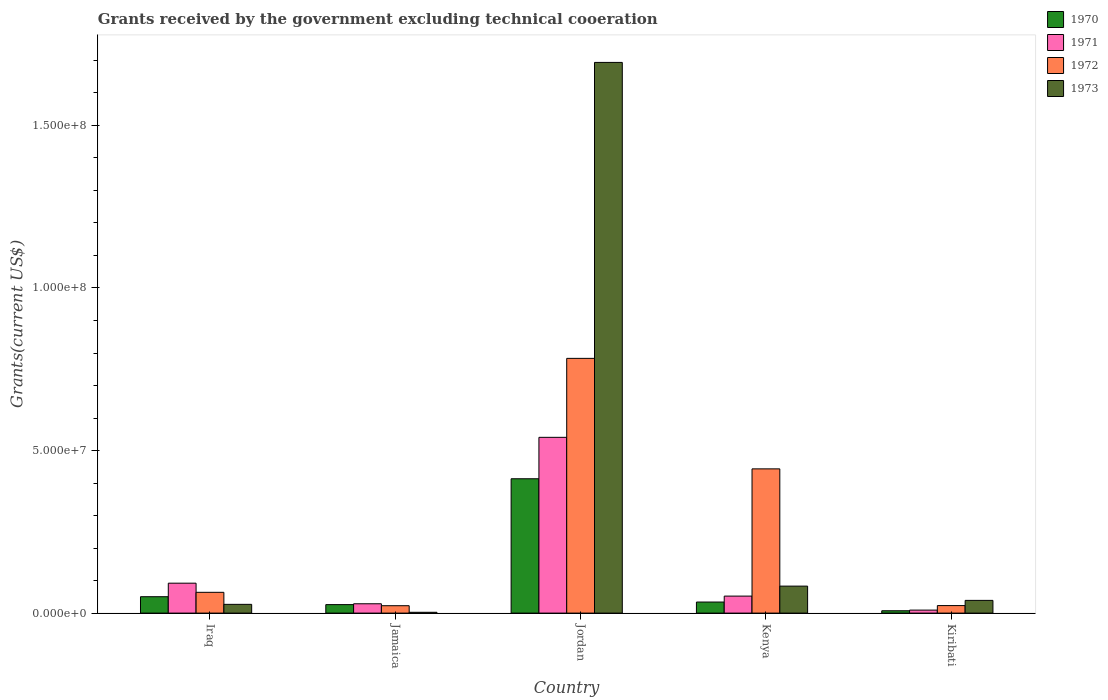How many different coloured bars are there?
Keep it short and to the point. 4. How many groups of bars are there?
Make the answer very short. 5. How many bars are there on the 3rd tick from the left?
Provide a short and direct response. 4. How many bars are there on the 2nd tick from the right?
Give a very brief answer. 4. What is the label of the 4th group of bars from the left?
Provide a succinct answer. Kenya. What is the total grants received by the government in 1970 in Kenya?
Give a very brief answer. 3.40e+06. Across all countries, what is the maximum total grants received by the government in 1970?
Offer a terse response. 4.13e+07. Across all countries, what is the minimum total grants received by the government in 1972?
Give a very brief answer. 2.27e+06. In which country was the total grants received by the government in 1970 maximum?
Keep it short and to the point. Jordan. In which country was the total grants received by the government in 1972 minimum?
Ensure brevity in your answer.  Jamaica. What is the total total grants received by the government in 1971 in the graph?
Give a very brief answer. 7.23e+07. What is the difference between the total grants received by the government in 1972 in Kenya and that in Kiribati?
Provide a succinct answer. 4.20e+07. What is the difference between the total grants received by the government in 1971 in Kenya and the total grants received by the government in 1973 in Jamaica?
Your answer should be compact. 4.98e+06. What is the average total grants received by the government in 1972 per country?
Make the answer very short. 2.67e+07. What is the difference between the total grants received by the government of/in 1973 and total grants received by the government of/in 1972 in Jordan?
Offer a very short reply. 9.10e+07. What is the ratio of the total grants received by the government in 1972 in Jamaica to that in Kiribati?
Your answer should be compact. 0.98. What is the difference between the highest and the second highest total grants received by the government in 1972?
Give a very brief answer. 7.20e+07. What is the difference between the highest and the lowest total grants received by the government in 1973?
Your response must be concise. 1.69e+08. What does the 2nd bar from the left in Jamaica represents?
Your answer should be very brief. 1971. Is it the case that in every country, the sum of the total grants received by the government in 1971 and total grants received by the government in 1970 is greater than the total grants received by the government in 1972?
Give a very brief answer. No. How many bars are there?
Ensure brevity in your answer.  20. How many countries are there in the graph?
Provide a succinct answer. 5. What is the difference between two consecutive major ticks on the Y-axis?
Make the answer very short. 5.00e+07. Does the graph contain grids?
Your response must be concise. No. How many legend labels are there?
Your answer should be very brief. 4. What is the title of the graph?
Keep it short and to the point. Grants received by the government excluding technical cooeration. What is the label or title of the Y-axis?
Your answer should be very brief. Grants(current US$). What is the Grants(current US$) of 1970 in Iraq?
Your response must be concise. 5.04e+06. What is the Grants(current US$) in 1971 in Iraq?
Provide a succinct answer. 9.20e+06. What is the Grants(current US$) in 1972 in Iraq?
Provide a succinct answer. 6.39e+06. What is the Grants(current US$) of 1973 in Iraq?
Provide a short and direct response. 2.69e+06. What is the Grants(current US$) in 1970 in Jamaica?
Your answer should be very brief. 2.61e+06. What is the Grants(current US$) of 1971 in Jamaica?
Provide a short and direct response. 2.87e+06. What is the Grants(current US$) in 1972 in Jamaica?
Keep it short and to the point. 2.27e+06. What is the Grants(current US$) of 1970 in Jordan?
Give a very brief answer. 4.13e+07. What is the Grants(current US$) of 1971 in Jordan?
Ensure brevity in your answer.  5.41e+07. What is the Grants(current US$) of 1972 in Jordan?
Provide a short and direct response. 7.84e+07. What is the Grants(current US$) of 1973 in Jordan?
Make the answer very short. 1.69e+08. What is the Grants(current US$) of 1970 in Kenya?
Offer a very short reply. 3.40e+06. What is the Grants(current US$) in 1971 in Kenya?
Offer a very short reply. 5.23e+06. What is the Grants(current US$) in 1972 in Kenya?
Your answer should be very brief. 4.44e+07. What is the Grants(current US$) in 1973 in Kenya?
Your response must be concise. 8.30e+06. What is the Grants(current US$) in 1970 in Kiribati?
Keep it short and to the point. 7.20e+05. What is the Grants(current US$) of 1971 in Kiribati?
Make the answer very short. 9.20e+05. What is the Grants(current US$) of 1972 in Kiribati?
Provide a succinct answer. 2.31e+06. What is the Grants(current US$) of 1973 in Kiribati?
Offer a very short reply. 3.91e+06. Across all countries, what is the maximum Grants(current US$) in 1970?
Your answer should be compact. 4.13e+07. Across all countries, what is the maximum Grants(current US$) in 1971?
Your response must be concise. 5.41e+07. Across all countries, what is the maximum Grants(current US$) of 1972?
Provide a succinct answer. 7.84e+07. Across all countries, what is the maximum Grants(current US$) in 1973?
Keep it short and to the point. 1.69e+08. Across all countries, what is the minimum Grants(current US$) in 1970?
Provide a short and direct response. 7.20e+05. Across all countries, what is the minimum Grants(current US$) of 1971?
Your answer should be compact. 9.20e+05. Across all countries, what is the minimum Grants(current US$) in 1972?
Keep it short and to the point. 2.27e+06. What is the total Grants(current US$) in 1970 in the graph?
Give a very brief answer. 5.31e+07. What is the total Grants(current US$) of 1971 in the graph?
Ensure brevity in your answer.  7.23e+07. What is the total Grants(current US$) of 1972 in the graph?
Provide a short and direct response. 1.34e+08. What is the total Grants(current US$) of 1973 in the graph?
Your answer should be very brief. 1.85e+08. What is the difference between the Grants(current US$) of 1970 in Iraq and that in Jamaica?
Offer a terse response. 2.43e+06. What is the difference between the Grants(current US$) in 1971 in Iraq and that in Jamaica?
Your answer should be compact. 6.33e+06. What is the difference between the Grants(current US$) of 1972 in Iraq and that in Jamaica?
Provide a succinct answer. 4.12e+06. What is the difference between the Grants(current US$) in 1973 in Iraq and that in Jamaica?
Ensure brevity in your answer.  2.44e+06. What is the difference between the Grants(current US$) in 1970 in Iraq and that in Jordan?
Give a very brief answer. -3.63e+07. What is the difference between the Grants(current US$) in 1971 in Iraq and that in Jordan?
Provide a short and direct response. -4.49e+07. What is the difference between the Grants(current US$) in 1972 in Iraq and that in Jordan?
Your response must be concise. -7.20e+07. What is the difference between the Grants(current US$) in 1973 in Iraq and that in Jordan?
Make the answer very short. -1.67e+08. What is the difference between the Grants(current US$) of 1970 in Iraq and that in Kenya?
Offer a terse response. 1.64e+06. What is the difference between the Grants(current US$) in 1971 in Iraq and that in Kenya?
Offer a terse response. 3.97e+06. What is the difference between the Grants(current US$) of 1972 in Iraq and that in Kenya?
Make the answer very short. -3.80e+07. What is the difference between the Grants(current US$) in 1973 in Iraq and that in Kenya?
Give a very brief answer. -5.61e+06. What is the difference between the Grants(current US$) in 1970 in Iraq and that in Kiribati?
Provide a succinct answer. 4.32e+06. What is the difference between the Grants(current US$) of 1971 in Iraq and that in Kiribati?
Ensure brevity in your answer.  8.28e+06. What is the difference between the Grants(current US$) in 1972 in Iraq and that in Kiribati?
Provide a short and direct response. 4.08e+06. What is the difference between the Grants(current US$) of 1973 in Iraq and that in Kiribati?
Your answer should be very brief. -1.22e+06. What is the difference between the Grants(current US$) in 1970 in Jamaica and that in Jordan?
Give a very brief answer. -3.87e+07. What is the difference between the Grants(current US$) of 1971 in Jamaica and that in Jordan?
Your answer should be compact. -5.12e+07. What is the difference between the Grants(current US$) of 1972 in Jamaica and that in Jordan?
Your answer should be very brief. -7.61e+07. What is the difference between the Grants(current US$) of 1973 in Jamaica and that in Jordan?
Offer a very short reply. -1.69e+08. What is the difference between the Grants(current US$) of 1970 in Jamaica and that in Kenya?
Provide a short and direct response. -7.90e+05. What is the difference between the Grants(current US$) of 1971 in Jamaica and that in Kenya?
Your answer should be very brief. -2.36e+06. What is the difference between the Grants(current US$) in 1972 in Jamaica and that in Kenya?
Ensure brevity in your answer.  -4.21e+07. What is the difference between the Grants(current US$) of 1973 in Jamaica and that in Kenya?
Give a very brief answer. -8.05e+06. What is the difference between the Grants(current US$) in 1970 in Jamaica and that in Kiribati?
Ensure brevity in your answer.  1.89e+06. What is the difference between the Grants(current US$) in 1971 in Jamaica and that in Kiribati?
Offer a terse response. 1.95e+06. What is the difference between the Grants(current US$) in 1973 in Jamaica and that in Kiribati?
Provide a succinct answer. -3.66e+06. What is the difference between the Grants(current US$) of 1970 in Jordan and that in Kenya?
Provide a succinct answer. 3.79e+07. What is the difference between the Grants(current US$) of 1971 in Jordan and that in Kenya?
Your answer should be very brief. 4.88e+07. What is the difference between the Grants(current US$) of 1972 in Jordan and that in Kenya?
Give a very brief answer. 3.40e+07. What is the difference between the Grants(current US$) of 1973 in Jordan and that in Kenya?
Keep it short and to the point. 1.61e+08. What is the difference between the Grants(current US$) of 1970 in Jordan and that in Kiribati?
Give a very brief answer. 4.06e+07. What is the difference between the Grants(current US$) of 1971 in Jordan and that in Kiribati?
Provide a succinct answer. 5.31e+07. What is the difference between the Grants(current US$) in 1972 in Jordan and that in Kiribati?
Give a very brief answer. 7.60e+07. What is the difference between the Grants(current US$) of 1973 in Jordan and that in Kiribati?
Give a very brief answer. 1.65e+08. What is the difference between the Grants(current US$) of 1970 in Kenya and that in Kiribati?
Provide a short and direct response. 2.68e+06. What is the difference between the Grants(current US$) of 1971 in Kenya and that in Kiribati?
Your response must be concise. 4.31e+06. What is the difference between the Grants(current US$) of 1972 in Kenya and that in Kiribati?
Keep it short and to the point. 4.20e+07. What is the difference between the Grants(current US$) of 1973 in Kenya and that in Kiribati?
Provide a succinct answer. 4.39e+06. What is the difference between the Grants(current US$) in 1970 in Iraq and the Grants(current US$) in 1971 in Jamaica?
Your answer should be very brief. 2.17e+06. What is the difference between the Grants(current US$) in 1970 in Iraq and the Grants(current US$) in 1972 in Jamaica?
Provide a short and direct response. 2.77e+06. What is the difference between the Grants(current US$) in 1970 in Iraq and the Grants(current US$) in 1973 in Jamaica?
Your answer should be very brief. 4.79e+06. What is the difference between the Grants(current US$) in 1971 in Iraq and the Grants(current US$) in 1972 in Jamaica?
Provide a succinct answer. 6.93e+06. What is the difference between the Grants(current US$) in 1971 in Iraq and the Grants(current US$) in 1973 in Jamaica?
Keep it short and to the point. 8.95e+06. What is the difference between the Grants(current US$) in 1972 in Iraq and the Grants(current US$) in 1973 in Jamaica?
Your answer should be very brief. 6.14e+06. What is the difference between the Grants(current US$) of 1970 in Iraq and the Grants(current US$) of 1971 in Jordan?
Provide a short and direct response. -4.90e+07. What is the difference between the Grants(current US$) in 1970 in Iraq and the Grants(current US$) in 1972 in Jordan?
Offer a very short reply. -7.33e+07. What is the difference between the Grants(current US$) of 1970 in Iraq and the Grants(current US$) of 1973 in Jordan?
Provide a short and direct response. -1.64e+08. What is the difference between the Grants(current US$) of 1971 in Iraq and the Grants(current US$) of 1972 in Jordan?
Keep it short and to the point. -6.92e+07. What is the difference between the Grants(current US$) in 1971 in Iraq and the Grants(current US$) in 1973 in Jordan?
Provide a succinct answer. -1.60e+08. What is the difference between the Grants(current US$) in 1972 in Iraq and the Grants(current US$) in 1973 in Jordan?
Give a very brief answer. -1.63e+08. What is the difference between the Grants(current US$) of 1970 in Iraq and the Grants(current US$) of 1972 in Kenya?
Ensure brevity in your answer.  -3.93e+07. What is the difference between the Grants(current US$) of 1970 in Iraq and the Grants(current US$) of 1973 in Kenya?
Keep it short and to the point. -3.26e+06. What is the difference between the Grants(current US$) in 1971 in Iraq and the Grants(current US$) in 1972 in Kenya?
Give a very brief answer. -3.52e+07. What is the difference between the Grants(current US$) of 1972 in Iraq and the Grants(current US$) of 1973 in Kenya?
Provide a short and direct response. -1.91e+06. What is the difference between the Grants(current US$) in 1970 in Iraq and the Grants(current US$) in 1971 in Kiribati?
Offer a terse response. 4.12e+06. What is the difference between the Grants(current US$) in 1970 in Iraq and the Grants(current US$) in 1972 in Kiribati?
Keep it short and to the point. 2.73e+06. What is the difference between the Grants(current US$) of 1970 in Iraq and the Grants(current US$) of 1973 in Kiribati?
Give a very brief answer. 1.13e+06. What is the difference between the Grants(current US$) of 1971 in Iraq and the Grants(current US$) of 1972 in Kiribati?
Provide a succinct answer. 6.89e+06. What is the difference between the Grants(current US$) in 1971 in Iraq and the Grants(current US$) in 1973 in Kiribati?
Your response must be concise. 5.29e+06. What is the difference between the Grants(current US$) in 1972 in Iraq and the Grants(current US$) in 1973 in Kiribati?
Offer a very short reply. 2.48e+06. What is the difference between the Grants(current US$) of 1970 in Jamaica and the Grants(current US$) of 1971 in Jordan?
Provide a short and direct response. -5.14e+07. What is the difference between the Grants(current US$) in 1970 in Jamaica and the Grants(current US$) in 1972 in Jordan?
Offer a terse response. -7.57e+07. What is the difference between the Grants(current US$) in 1970 in Jamaica and the Grants(current US$) in 1973 in Jordan?
Ensure brevity in your answer.  -1.67e+08. What is the difference between the Grants(current US$) of 1971 in Jamaica and the Grants(current US$) of 1972 in Jordan?
Ensure brevity in your answer.  -7.55e+07. What is the difference between the Grants(current US$) in 1971 in Jamaica and the Grants(current US$) in 1973 in Jordan?
Ensure brevity in your answer.  -1.67e+08. What is the difference between the Grants(current US$) in 1972 in Jamaica and the Grants(current US$) in 1973 in Jordan?
Provide a succinct answer. -1.67e+08. What is the difference between the Grants(current US$) in 1970 in Jamaica and the Grants(current US$) in 1971 in Kenya?
Provide a succinct answer. -2.62e+06. What is the difference between the Grants(current US$) in 1970 in Jamaica and the Grants(current US$) in 1972 in Kenya?
Your answer should be compact. -4.18e+07. What is the difference between the Grants(current US$) in 1970 in Jamaica and the Grants(current US$) in 1973 in Kenya?
Provide a succinct answer. -5.69e+06. What is the difference between the Grants(current US$) of 1971 in Jamaica and the Grants(current US$) of 1972 in Kenya?
Make the answer very short. -4.15e+07. What is the difference between the Grants(current US$) in 1971 in Jamaica and the Grants(current US$) in 1973 in Kenya?
Keep it short and to the point. -5.43e+06. What is the difference between the Grants(current US$) in 1972 in Jamaica and the Grants(current US$) in 1973 in Kenya?
Ensure brevity in your answer.  -6.03e+06. What is the difference between the Grants(current US$) of 1970 in Jamaica and the Grants(current US$) of 1971 in Kiribati?
Make the answer very short. 1.69e+06. What is the difference between the Grants(current US$) of 1970 in Jamaica and the Grants(current US$) of 1973 in Kiribati?
Ensure brevity in your answer.  -1.30e+06. What is the difference between the Grants(current US$) of 1971 in Jamaica and the Grants(current US$) of 1972 in Kiribati?
Your answer should be very brief. 5.60e+05. What is the difference between the Grants(current US$) in 1971 in Jamaica and the Grants(current US$) in 1973 in Kiribati?
Your answer should be very brief. -1.04e+06. What is the difference between the Grants(current US$) in 1972 in Jamaica and the Grants(current US$) in 1973 in Kiribati?
Offer a terse response. -1.64e+06. What is the difference between the Grants(current US$) of 1970 in Jordan and the Grants(current US$) of 1971 in Kenya?
Ensure brevity in your answer.  3.61e+07. What is the difference between the Grants(current US$) in 1970 in Jordan and the Grants(current US$) in 1972 in Kenya?
Offer a terse response. -3.04e+06. What is the difference between the Grants(current US$) in 1970 in Jordan and the Grants(current US$) in 1973 in Kenya?
Provide a short and direct response. 3.30e+07. What is the difference between the Grants(current US$) of 1971 in Jordan and the Grants(current US$) of 1972 in Kenya?
Keep it short and to the point. 9.70e+06. What is the difference between the Grants(current US$) in 1971 in Jordan and the Grants(current US$) in 1973 in Kenya?
Give a very brief answer. 4.58e+07. What is the difference between the Grants(current US$) of 1972 in Jordan and the Grants(current US$) of 1973 in Kenya?
Keep it short and to the point. 7.00e+07. What is the difference between the Grants(current US$) in 1970 in Jordan and the Grants(current US$) in 1971 in Kiribati?
Keep it short and to the point. 4.04e+07. What is the difference between the Grants(current US$) in 1970 in Jordan and the Grants(current US$) in 1972 in Kiribati?
Offer a very short reply. 3.90e+07. What is the difference between the Grants(current US$) in 1970 in Jordan and the Grants(current US$) in 1973 in Kiribati?
Provide a short and direct response. 3.74e+07. What is the difference between the Grants(current US$) of 1971 in Jordan and the Grants(current US$) of 1972 in Kiribati?
Make the answer very short. 5.18e+07. What is the difference between the Grants(current US$) in 1971 in Jordan and the Grants(current US$) in 1973 in Kiribati?
Offer a terse response. 5.02e+07. What is the difference between the Grants(current US$) of 1972 in Jordan and the Grants(current US$) of 1973 in Kiribati?
Provide a succinct answer. 7.44e+07. What is the difference between the Grants(current US$) of 1970 in Kenya and the Grants(current US$) of 1971 in Kiribati?
Ensure brevity in your answer.  2.48e+06. What is the difference between the Grants(current US$) of 1970 in Kenya and the Grants(current US$) of 1972 in Kiribati?
Provide a short and direct response. 1.09e+06. What is the difference between the Grants(current US$) of 1970 in Kenya and the Grants(current US$) of 1973 in Kiribati?
Your answer should be very brief. -5.10e+05. What is the difference between the Grants(current US$) in 1971 in Kenya and the Grants(current US$) in 1972 in Kiribati?
Offer a terse response. 2.92e+06. What is the difference between the Grants(current US$) in 1971 in Kenya and the Grants(current US$) in 1973 in Kiribati?
Give a very brief answer. 1.32e+06. What is the difference between the Grants(current US$) in 1972 in Kenya and the Grants(current US$) in 1973 in Kiribati?
Keep it short and to the point. 4.04e+07. What is the average Grants(current US$) of 1970 per country?
Keep it short and to the point. 1.06e+07. What is the average Grants(current US$) of 1971 per country?
Keep it short and to the point. 1.45e+07. What is the average Grants(current US$) of 1972 per country?
Your answer should be compact. 2.67e+07. What is the average Grants(current US$) of 1973 per country?
Make the answer very short. 3.69e+07. What is the difference between the Grants(current US$) of 1970 and Grants(current US$) of 1971 in Iraq?
Ensure brevity in your answer.  -4.16e+06. What is the difference between the Grants(current US$) of 1970 and Grants(current US$) of 1972 in Iraq?
Provide a succinct answer. -1.35e+06. What is the difference between the Grants(current US$) of 1970 and Grants(current US$) of 1973 in Iraq?
Your answer should be compact. 2.35e+06. What is the difference between the Grants(current US$) in 1971 and Grants(current US$) in 1972 in Iraq?
Provide a succinct answer. 2.81e+06. What is the difference between the Grants(current US$) in 1971 and Grants(current US$) in 1973 in Iraq?
Your answer should be very brief. 6.51e+06. What is the difference between the Grants(current US$) of 1972 and Grants(current US$) of 1973 in Iraq?
Offer a terse response. 3.70e+06. What is the difference between the Grants(current US$) of 1970 and Grants(current US$) of 1971 in Jamaica?
Offer a terse response. -2.60e+05. What is the difference between the Grants(current US$) of 1970 and Grants(current US$) of 1973 in Jamaica?
Ensure brevity in your answer.  2.36e+06. What is the difference between the Grants(current US$) in 1971 and Grants(current US$) in 1973 in Jamaica?
Your response must be concise. 2.62e+06. What is the difference between the Grants(current US$) in 1972 and Grants(current US$) in 1973 in Jamaica?
Your response must be concise. 2.02e+06. What is the difference between the Grants(current US$) of 1970 and Grants(current US$) of 1971 in Jordan?
Your answer should be compact. -1.27e+07. What is the difference between the Grants(current US$) of 1970 and Grants(current US$) of 1972 in Jordan?
Offer a terse response. -3.70e+07. What is the difference between the Grants(current US$) in 1970 and Grants(current US$) in 1973 in Jordan?
Provide a short and direct response. -1.28e+08. What is the difference between the Grants(current US$) of 1971 and Grants(current US$) of 1972 in Jordan?
Provide a short and direct response. -2.43e+07. What is the difference between the Grants(current US$) of 1971 and Grants(current US$) of 1973 in Jordan?
Provide a succinct answer. -1.15e+08. What is the difference between the Grants(current US$) in 1972 and Grants(current US$) in 1973 in Jordan?
Ensure brevity in your answer.  -9.10e+07. What is the difference between the Grants(current US$) of 1970 and Grants(current US$) of 1971 in Kenya?
Ensure brevity in your answer.  -1.83e+06. What is the difference between the Grants(current US$) of 1970 and Grants(current US$) of 1972 in Kenya?
Your answer should be very brief. -4.10e+07. What is the difference between the Grants(current US$) in 1970 and Grants(current US$) in 1973 in Kenya?
Offer a very short reply. -4.90e+06. What is the difference between the Grants(current US$) of 1971 and Grants(current US$) of 1972 in Kenya?
Your answer should be compact. -3.91e+07. What is the difference between the Grants(current US$) in 1971 and Grants(current US$) in 1973 in Kenya?
Your answer should be compact. -3.07e+06. What is the difference between the Grants(current US$) in 1972 and Grants(current US$) in 1973 in Kenya?
Provide a succinct answer. 3.61e+07. What is the difference between the Grants(current US$) in 1970 and Grants(current US$) in 1971 in Kiribati?
Give a very brief answer. -2.00e+05. What is the difference between the Grants(current US$) in 1970 and Grants(current US$) in 1972 in Kiribati?
Your response must be concise. -1.59e+06. What is the difference between the Grants(current US$) of 1970 and Grants(current US$) of 1973 in Kiribati?
Give a very brief answer. -3.19e+06. What is the difference between the Grants(current US$) in 1971 and Grants(current US$) in 1972 in Kiribati?
Your response must be concise. -1.39e+06. What is the difference between the Grants(current US$) in 1971 and Grants(current US$) in 1973 in Kiribati?
Ensure brevity in your answer.  -2.99e+06. What is the difference between the Grants(current US$) in 1972 and Grants(current US$) in 1973 in Kiribati?
Give a very brief answer. -1.60e+06. What is the ratio of the Grants(current US$) in 1970 in Iraq to that in Jamaica?
Give a very brief answer. 1.93. What is the ratio of the Grants(current US$) of 1971 in Iraq to that in Jamaica?
Provide a succinct answer. 3.21. What is the ratio of the Grants(current US$) of 1972 in Iraq to that in Jamaica?
Offer a terse response. 2.81. What is the ratio of the Grants(current US$) in 1973 in Iraq to that in Jamaica?
Your response must be concise. 10.76. What is the ratio of the Grants(current US$) in 1970 in Iraq to that in Jordan?
Give a very brief answer. 0.12. What is the ratio of the Grants(current US$) of 1971 in Iraq to that in Jordan?
Keep it short and to the point. 0.17. What is the ratio of the Grants(current US$) in 1972 in Iraq to that in Jordan?
Your response must be concise. 0.08. What is the ratio of the Grants(current US$) in 1973 in Iraq to that in Jordan?
Your response must be concise. 0.02. What is the ratio of the Grants(current US$) in 1970 in Iraq to that in Kenya?
Keep it short and to the point. 1.48. What is the ratio of the Grants(current US$) of 1971 in Iraq to that in Kenya?
Ensure brevity in your answer.  1.76. What is the ratio of the Grants(current US$) in 1972 in Iraq to that in Kenya?
Give a very brief answer. 0.14. What is the ratio of the Grants(current US$) of 1973 in Iraq to that in Kenya?
Make the answer very short. 0.32. What is the ratio of the Grants(current US$) of 1970 in Iraq to that in Kiribati?
Ensure brevity in your answer.  7. What is the ratio of the Grants(current US$) of 1972 in Iraq to that in Kiribati?
Offer a very short reply. 2.77. What is the ratio of the Grants(current US$) in 1973 in Iraq to that in Kiribati?
Your response must be concise. 0.69. What is the ratio of the Grants(current US$) of 1970 in Jamaica to that in Jordan?
Ensure brevity in your answer.  0.06. What is the ratio of the Grants(current US$) of 1971 in Jamaica to that in Jordan?
Your response must be concise. 0.05. What is the ratio of the Grants(current US$) of 1972 in Jamaica to that in Jordan?
Your answer should be very brief. 0.03. What is the ratio of the Grants(current US$) in 1973 in Jamaica to that in Jordan?
Offer a terse response. 0. What is the ratio of the Grants(current US$) in 1970 in Jamaica to that in Kenya?
Your answer should be compact. 0.77. What is the ratio of the Grants(current US$) in 1971 in Jamaica to that in Kenya?
Keep it short and to the point. 0.55. What is the ratio of the Grants(current US$) of 1972 in Jamaica to that in Kenya?
Give a very brief answer. 0.05. What is the ratio of the Grants(current US$) of 1973 in Jamaica to that in Kenya?
Your answer should be very brief. 0.03. What is the ratio of the Grants(current US$) in 1970 in Jamaica to that in Kiribati?
Keep it short and to the point. 3.62. What is the ratio of the Grants(current US$) of 1971 in Jamaica to that in Kiribati?
Ensure brevity in your answer.  3.12. What is the ratio of the Grants(current US$) in 1972 in Jamaica to that in Kiribati?
Give a very brief answer. 0.98. What is the ratio of the Grants(current US$) in 1973 in Jamaica to that in Kiribati?
Offer a terse response. 0.06. What is the ratio of the Grants(current US$) in 1970 in Jordan to that in Kenya?
Offer a terse response. 12.15. What is the ratio of the Grants(current US$) in 1971 in Jordan to that in Kenya?
Offer a very short reply. 10.34. What is the ratio of the Grants(current US$) in 1972 in Jordan to that in Kenya?
Offer a terse response. 1.77. What is the ratio of the Grants(current US$) in 1973 in Jordan to that in Kenya?
Your response must be concise. 20.41. What is the ratio of the Grants(current US$) in 1970 in Jordan to that in Kiribati?
Make the answer very short. 57.39. What is the ratio of the Grants(current US$) of 1971 in Jordan to that in Kiribati?
Your answer should be compact. 58.76. What is the ratio of the Grants(current US$) of 1972 in Jordan to that in Kiribati?
Give a very brief answer. 33.92. What is the ratio of the Grants(current US$) of 1973 in Jordan to that in Kiribati?
Provide a succinct answer. 43.32. What is the ratio of the Grants(current US$) in 1970 in Kenya to that in Kiribati?
Keep it short and to the point. 4.72. What is the ratio of the Grants(current US$) in 1971 in Kenya to that in Kiribati?
Your answer should be compact. 5.68. What is the ratio of the Grants(current US$) in 1972 in Kenya to that in Kiribati?
Your answer should be very brief. 19.2. What is the ratio of the Grants(current US$) in 1973 in Kenya to that in Kiribati?
Your answer should be very brief. 2.12. What is the difference between the highest and the second highest Grants(current US$) in 1970?
Make the answer very short. 3.63e+07. What is the difference between the highest and the second highest Grants(current US$) of 1971?
Provide a short and direct response. 4.49e+07. What is the difference between the highest and the second highest Grants(current US$) of 1972?
Offer a very short reply. 3.40e+07. What is the difference between the highest and the second highest Grants(current US$) of 1973?
Make the answer very short. 1.61e+08. What is the difference between the highest and the lowest Grants(current US$) of 1970?
Offer a very short reply. 4.06e+07. What is the difference between the highest and the lowest Grants(current US$) in 1971?
Offer a terse response. 5.31e+07. What is the difference between the highest and the lowest Grants(current US$) of 1972?
Provide a succinct answer. 7.61e+07. What is the difference between the highest and the lowest Grants(current US$) in 1973?
Ensure brevity in your answer.  1.69e+08. 